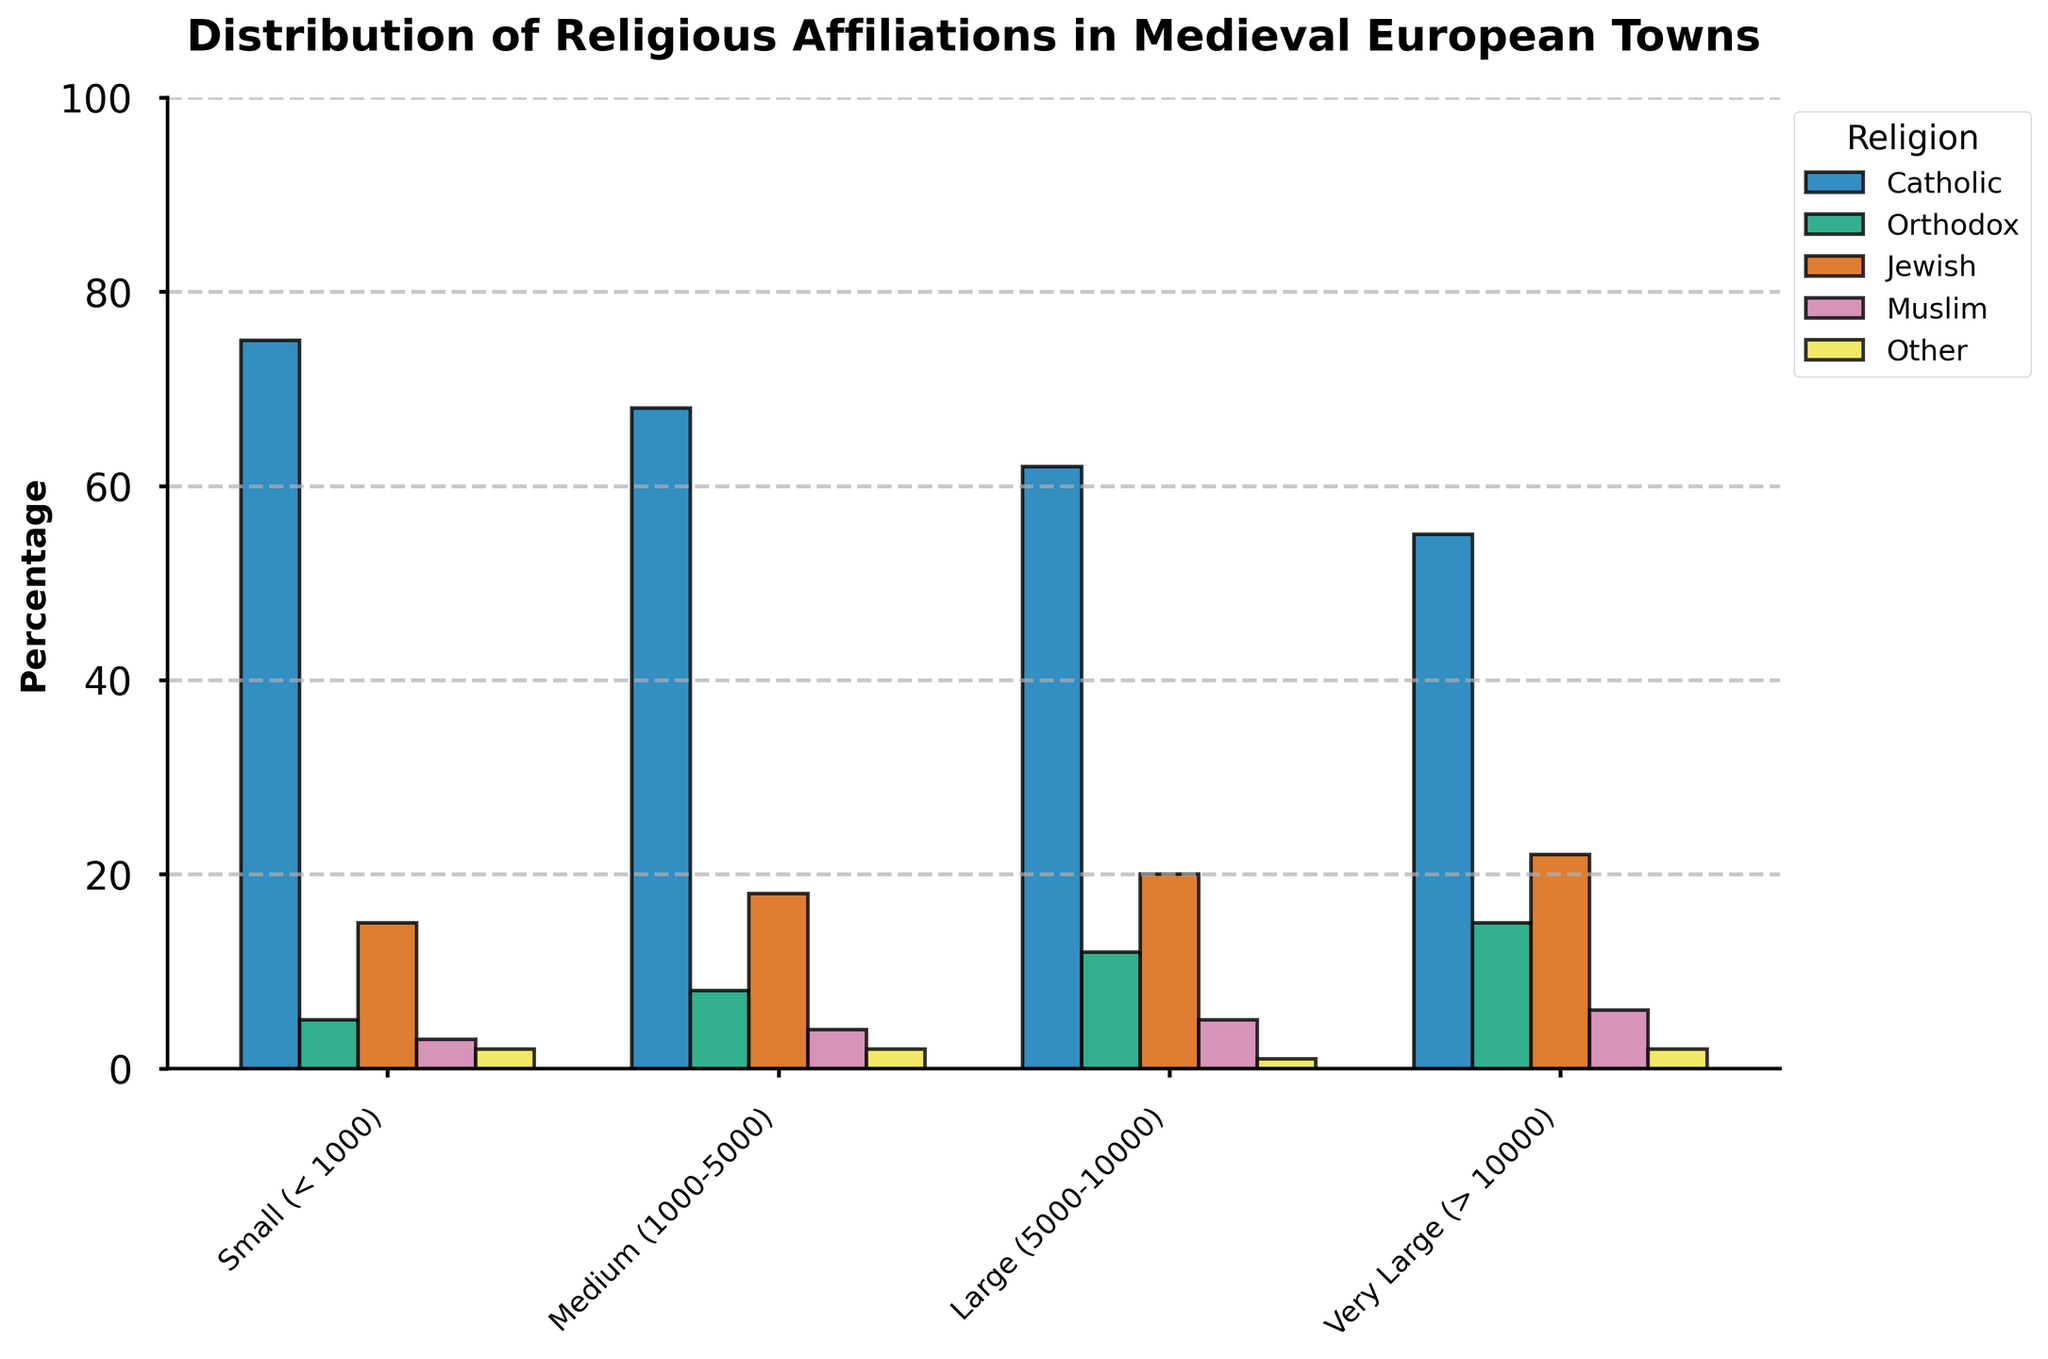What percentage of Catholics are there in very large towns? The bar representing Catholics in very large towns shows a height corresponding to 55%.
Answer: 55% Which town size has the highest percentage of Orthodox residents? By comparing the heights of the bars for Orthodox residents across the different town sizes, the tallest bar is found in very large towns with a height of 15%.
Answer: Very large What is the difference in the percentage of Jewish residents between small and large towns? Small towns have a Jewish percentage of 15%, and large towns have a percentage of 20%. The difference is 20% - 15% = 5%.
Answer: 5% Compare the number of Muslim residents in small towns to that in medium towns. Small towns have a Muslim percentage of 3%, while medium towns have 4%. 4% is greater than 3%.
Answer: Medium towns have more What is the sum of the percentages of other religious groups across all town sizes? Sum the "Other" percentages: 2% (small) + 2% (medium) + 1% (large) + 2% (very large). 2 + 2 + 1 + 2 = 7.
Answer: 7% Which religious affiliation consistently decreases as the town size increases? By examining each bar for each religious group across increasing town sizes, the group with consistently decreasing bars is the Catholic group.
Answer: Catholic In which town size do Jewish residents have the highest percentage, and what is this percentage? The bar for Jewish residents is highest in very large towns, reaching up to 22%.
Answer: Very large, 22% Which religion is least represented in large towns? By comparing the heights of the bars for each religion in large towns, the "Other" religion has the lowest height at 1%.
Answer: Other Compare the overall distribution of religious affiliations between small and very large towns. Small towns have Catholics at 75%, Orthodox at 5%, Jewish at 15%, Muslim at 3%, and Other at 2%. Very large towns have Catholics at 55%, Orthodox at 15%, Jewish at 22%, Muslim at 6%, and Other at 2%. Catholics decrease, Orthodox, Jewish, and Muslim percentages increase, and Other remains the same.
Answer: Catholics decrease; Orthodox, Jewish, and Muslims increase; Other remains the same Which religious affiliation has the smallest difference in percentage between small and medium towns? Calculate the differences: Catholic (75%-68%=7%), Orthodox (8%-5%=3%), Jewish (18%-15%=3%), Muslim (4%-3%=1%), Other (2%-2%=0%). The smallest difference is for Other, which is 0%.
Answer: Other 